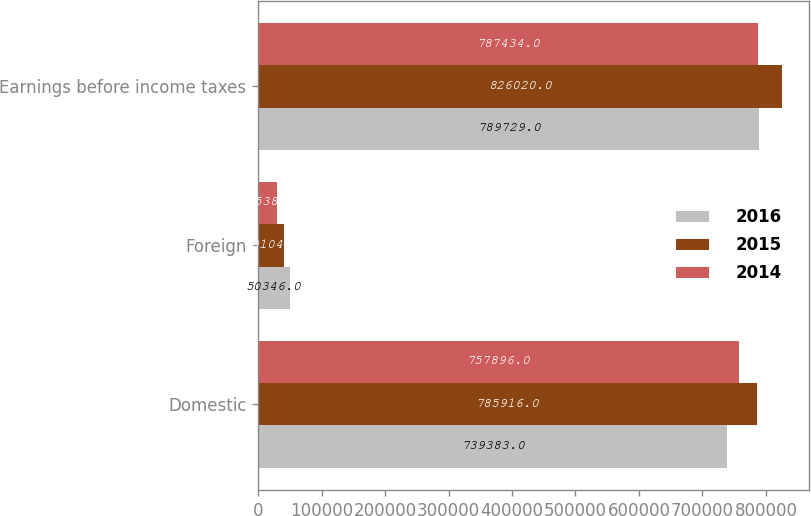Convert chart. <chart><loc_0><loc_0><loc_500><loc_500><stacked_bar_chart><ecel><fcel>Domestic<fcel>Foreign<fcel>Earnings before income taxes<nl><fcel>2016<fcel>739383<fcel>50346<fcel>789729<nl><fcel>2015<fcel>785916<fcel>40104<fcel>826020<nl><fcel>2014<fcel>757896<fcel>29538<fcel>787434<nl></chart> 